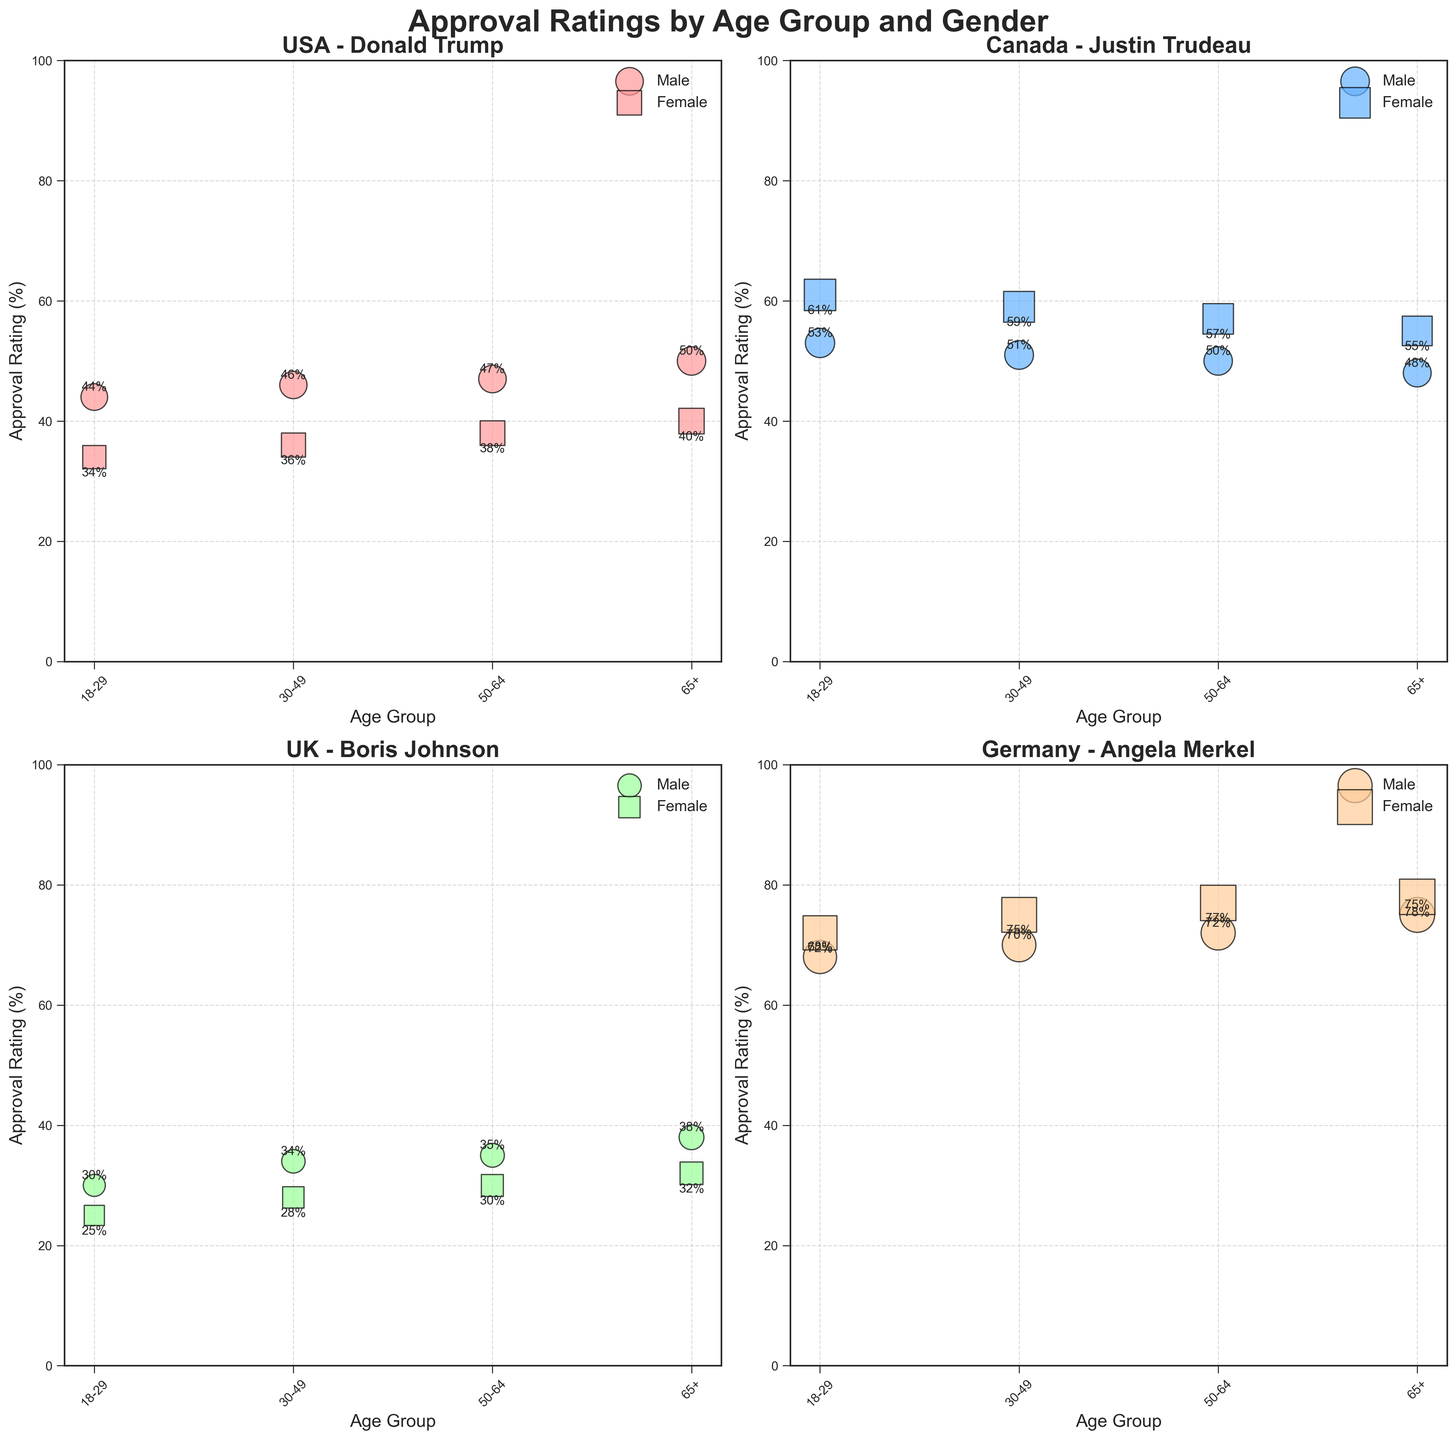What is the title of the figure? The title is located centrally at the top of the figure. It is clearly marked in a larger, bold font which is common in such visualizations for easy identification.
Answer: Approval Ratings by Age Group and Gender Which country in the figure has the highest approval rating for females aged 65+? By looking at the bubbles in each subplot representing the four countries, the largest bubble for females aged 65+ is in the subplot for Germany. The annotated percentage reads 78%.
Answer: Germany How do the approval ratings for males and females aged 18-29 in Canada compare? In the subplot for Canada, there are two sets of bubbles for the 18-29 age group. The male approval rating is 53%, while the female approval rating is 61%. Comparing these, females have a higher approval rating.
Answer: Females have a higher rating Is there any age group in the UK where approval ratings for both genders are equal? We need to compare the male and female approval ratings for each age group in the UK subplot. None of the male and female approval ratings in the same age group match.
Answer: No Which leader has the most uniform approval ratings across age groups for both genders? By looking at the subplots and the size and spread of the bubbles for each country, we see that Angela Merkel in Germany has consistently high approval ratings across all age groups and both genders.
Answer: Angela Merkel For which age group and gender does Donald Trump have his lowest approval rating? In the subplot for the USA and looking at the smallest bubbles representing Donald Trump’s approval across age groups and genders, the lowest rating is for females aged 18-29, which is 34%.
Answer: Females aged 18-29 Which country has the largest difference in approval ratings between males and females aged 50-64? By comparing the male and female approval ratings for the 50-64 age group across subplots, the largest difference appears in Germany, where the male rating is 72% and the female rating is 77%, a difference of 5%.
Answer: Germany What is the average approval rating for Justin Trudeau across all age groups for males? In the Canada subplot, the male ratings are 53%, 51%, 50%, and 48%. The average can be calculated as (53 + 51 + 50 + 48) / 4 = 202 / 4 = 50.5%.
Answer: 50.5% Which country showcases the least variation in approval ratings across different age groups for the same gender? To determine this, we look at the subplots and check for bubbles’ size stability across age groups for the same gender. Angela Merkel in Germany displays the least variation with consistently high bubbles in all groups.
Answer: Germany Among the four leaders, whose approval rating varies the most between the youngest and the oldest age groups for males? For each subplot, compare the approval ratings of the youngest (18-29) and oldest (65+) male age groups. The UK (Boris Johnson) shows the most significant variance, with ratings of 30% for 18-29 males and 38% for 65+ males, a difference of 8%.
Answer: Boris Johnson 